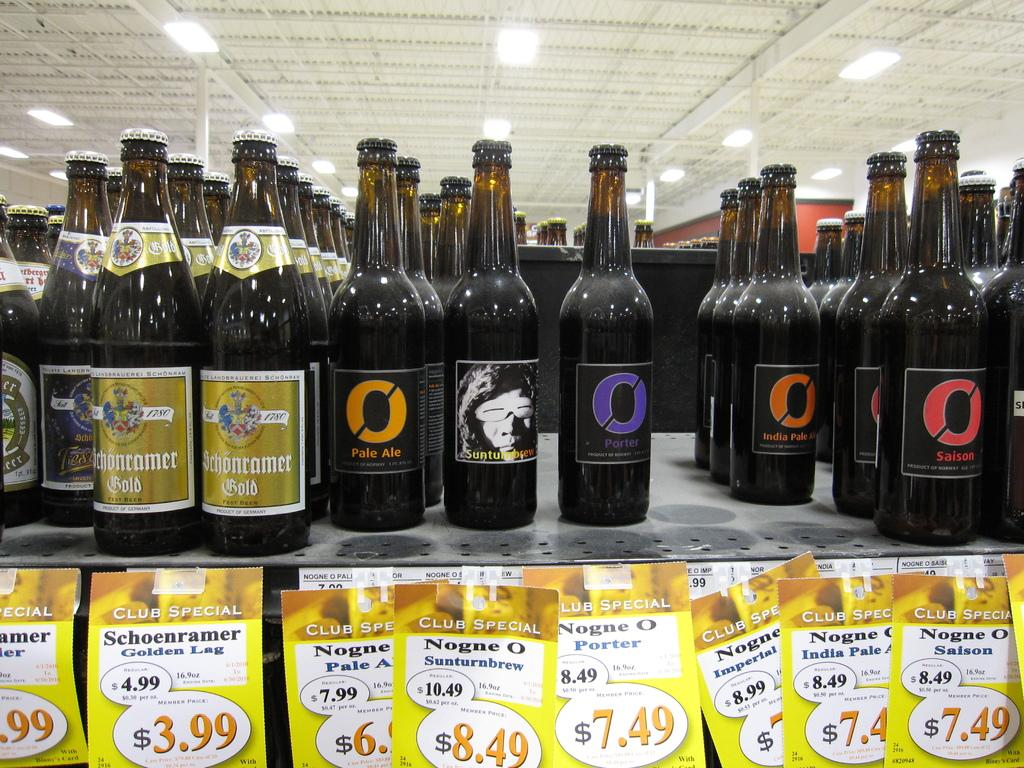What objects are present in the image that are typically used for holding liquids? There are bottles in the image. What other items can be seen in the image? There are papers in the image. What type of copper material can be seen in the image? There is no copper material present in the image. What color is the washbasin in the image? There is no washbasin present in the image. 